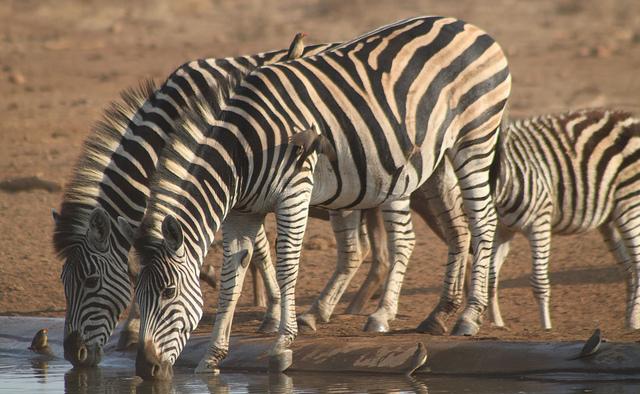How many zebra are  standing?
Answer briefly. 3. Does it look like it is cold out?
Answer briefly. No. How many zebras?
Answer briefly. 3. What are the zebras drinking?
Give a very brief answer. Water. How many zebras are drinking?
Quick response, please. 2. Are these zebras aware of the birds standing nearby?
Quick response, please. Yes. 